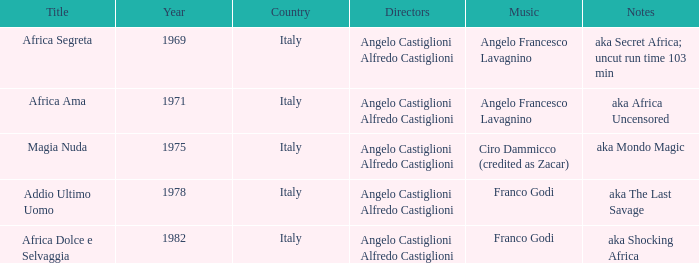Which music has the notes of AKA Africa Uncensored? Angelo Francesco Lavagnino. 